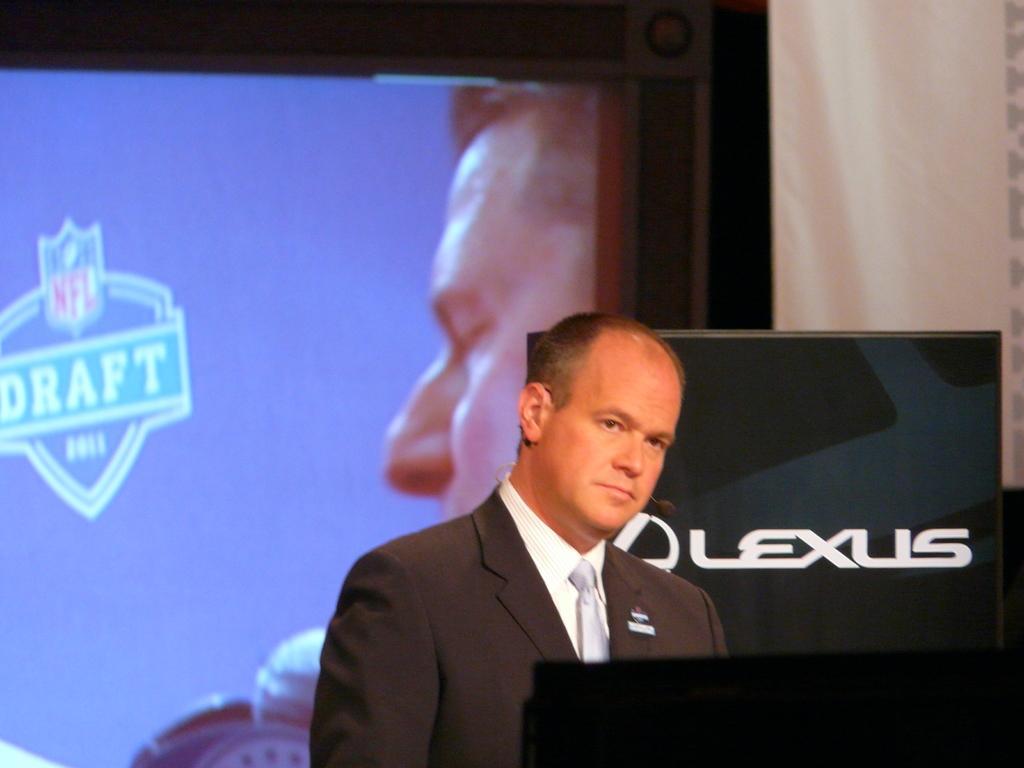Can you describe this image briefly? In this image I can see in the middle there is a man, he is wearing a coat, tie, shirt. On the left side it looks like a projector screen. 